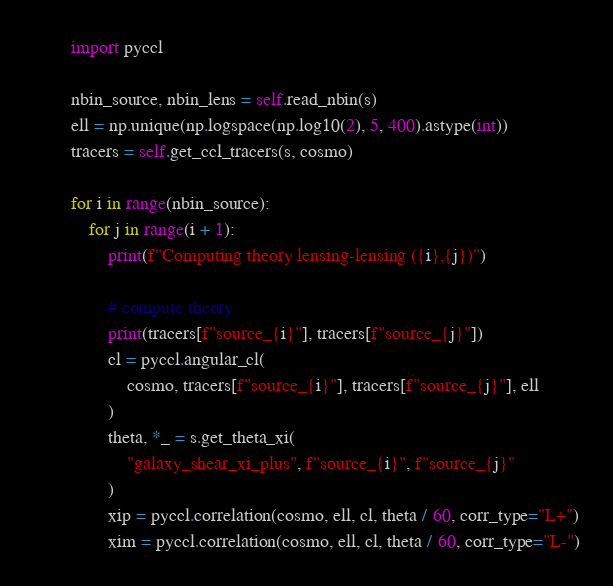<code> <loc_0><loc_0><loc_500><loc_500><_Python_>
        import pyccl

        nbin_source, nbin_lens = self.read_nbin(s)
        ell = np.unique(np.logspace(np.log10(2), 5, 400).astype(int))
        tracers = self.get_ccl_tracers(s, cosmo)

        for i in range(nbin_source):
            for j in range(i + 1):
                print(f"Computing theory lensing-lensing ({i},{j})")

                # compute theory
                print(tracers[f"source_{i}"], tracers[f"source_{j}"])
                cl = pyccl.angular_cl(
                    cosmo, tracers[f"source_{i}"], tracers[f"source_{j}"], ell
                )
                theta, *_ = s.get_theta_xi(
                    "galaxy_shear_xi_plus", f"source_{i}", f"source_{j}"
                )
                xip = pyccl.correlation(cosmo, ell, cl, theta / 60, corr_type="L+")
                xim = pyccl.correlation(cosmo, ell, cl, theta / 60, corr_type="L-")
</code> 